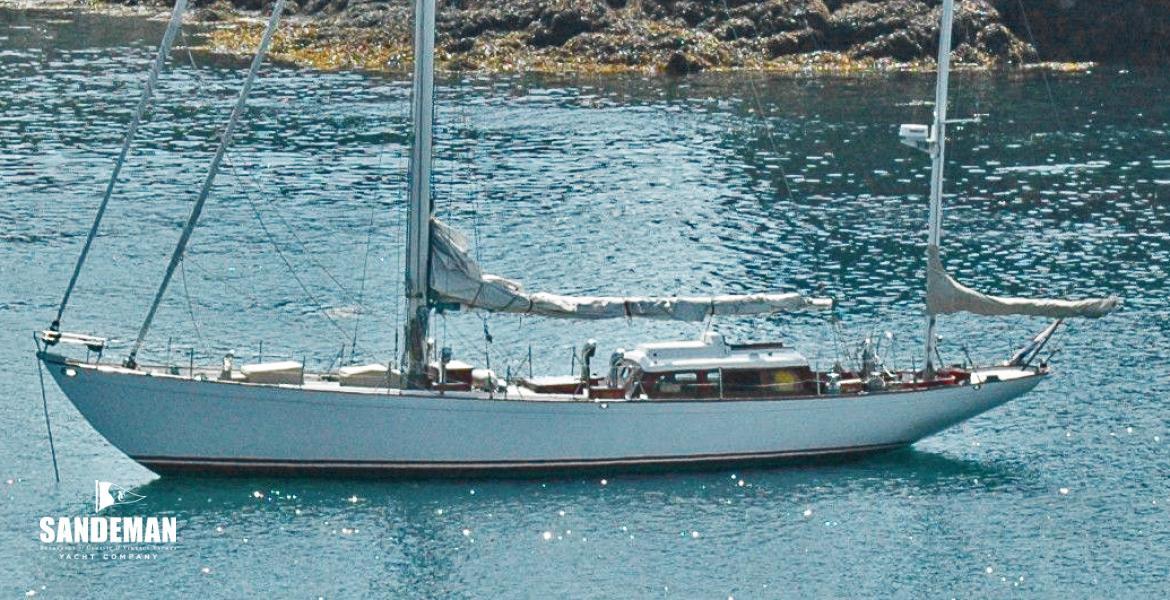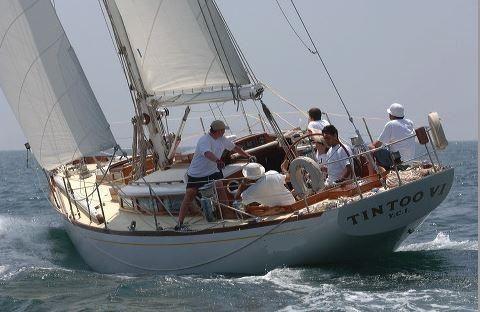The first image is the image on the left, the second image is the image on the right. Examine the images to the left and right. Is the description "One boat contains multiple people and creates white spray as it moves through water with unfurled sails, while the other boat is still and has furled sails." accurate? Answer yes or no. Yes. The first image is the image on the left, the second image is the image on the right. Assess this claim about the two images: "The left and right image contains the same number of sailboats with one with no sails out.". Correct or not? Answer yes or no. Yes. 